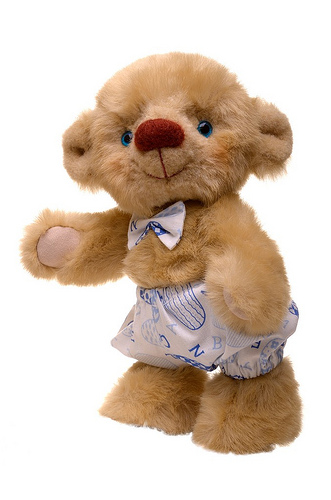<image>
Can you confirm if the bow is behind the pants? No. The bow is not behind the pants. From this viewpoint, the bow appears to be positioned elsewhere in the scene. 